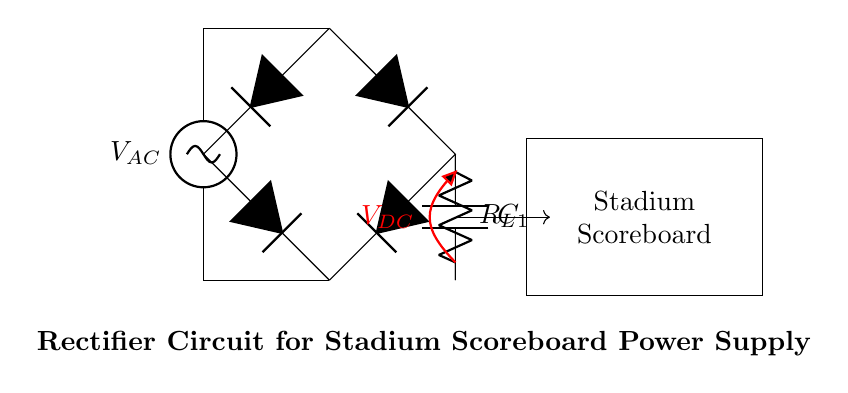What type of rectifier is used in this circuit? This circuit uses a bridge rectifier, as indicated by the configuration of the four diodes connected in a diamond shape between the AC source and the load.
Answer: bridge rectifier What is the function of the capacitor in this circuit? The capacitor smooths the output voltage by filtering the ripples in the direct current, providing a more stable output voltage to the load resistor.
Answer: smoothing What component is depicted as R_L? R_L represents the load resistor that delivers the electrical energy to the stadium scoreboard, allowing it to function correctly by converting electrical energy to light or digital signals.
Answer: load resistor What is the output voltage type of this rectifier circuit? The output voltage after the rectification is direct current (DC), as indicated by the notation and the open voltage connection marked by V_DC in the circuit.
Answer: direct current What would happen if the smoothing capacitor were removed? If the smoothing capacitor is removed, the output voltage would have significant ripples due to the pulsating nature of the rectified voltage, causing the scoreboard to flicker or behave erratically.
Answer: flickering How many diodes are used in this rectifier circuit? A total of four diodes are used in the bridge rectifier configuration, allowing current to flow in both directions while ensuring that the output is always positive.
Answer: four 